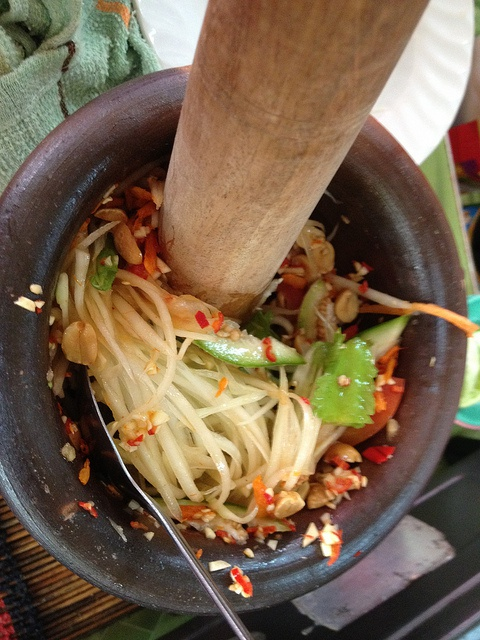Describe the objects in this image and their specific colors. I can see bowl in black, maroon, gray, and olive tones, knife in black, gray, maroon, and darkgray tones, and fork in black, gray, darkgray, and lavender tones in this image. 